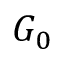Convert formula to latex. <formula><loc_0><loc_0><loc_500><loc_500>G _ { 0 }</formula> 